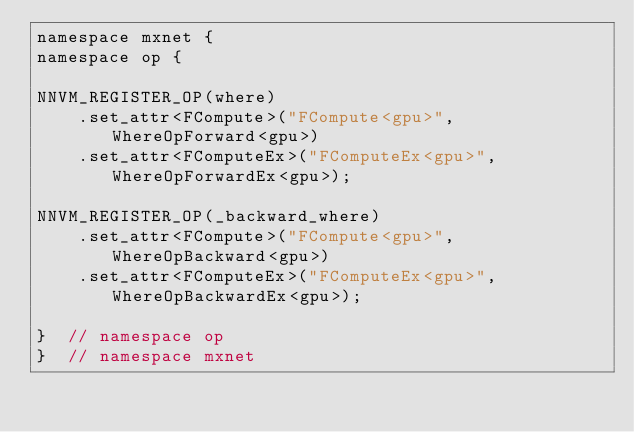<code> <loc_0><loc_0><loc_500><loc_500><_Cuda_>namespace mxnet {
namespace op {

NNVM_REGISTER_OP(where)
    .set_attr<FCompute>("FCompute<gpu>", WhereOpForward<gpu>)
    .set_attr<FComputeEx>("FComputeEx<gpu>", WhereOpForwardEx<gpu>);

NNVM_REGISTER_OP(_backward_where)
    .set_attr<FCompute>("FCompute<gpu>", WhereOpBackward<gpu>)
    .set_attr<FComputeEx>("FComputeEx<gpu>", WhereOpBackwardEx<gpu>);

}  // namespace op
}  // namespace mxnet
</code> 